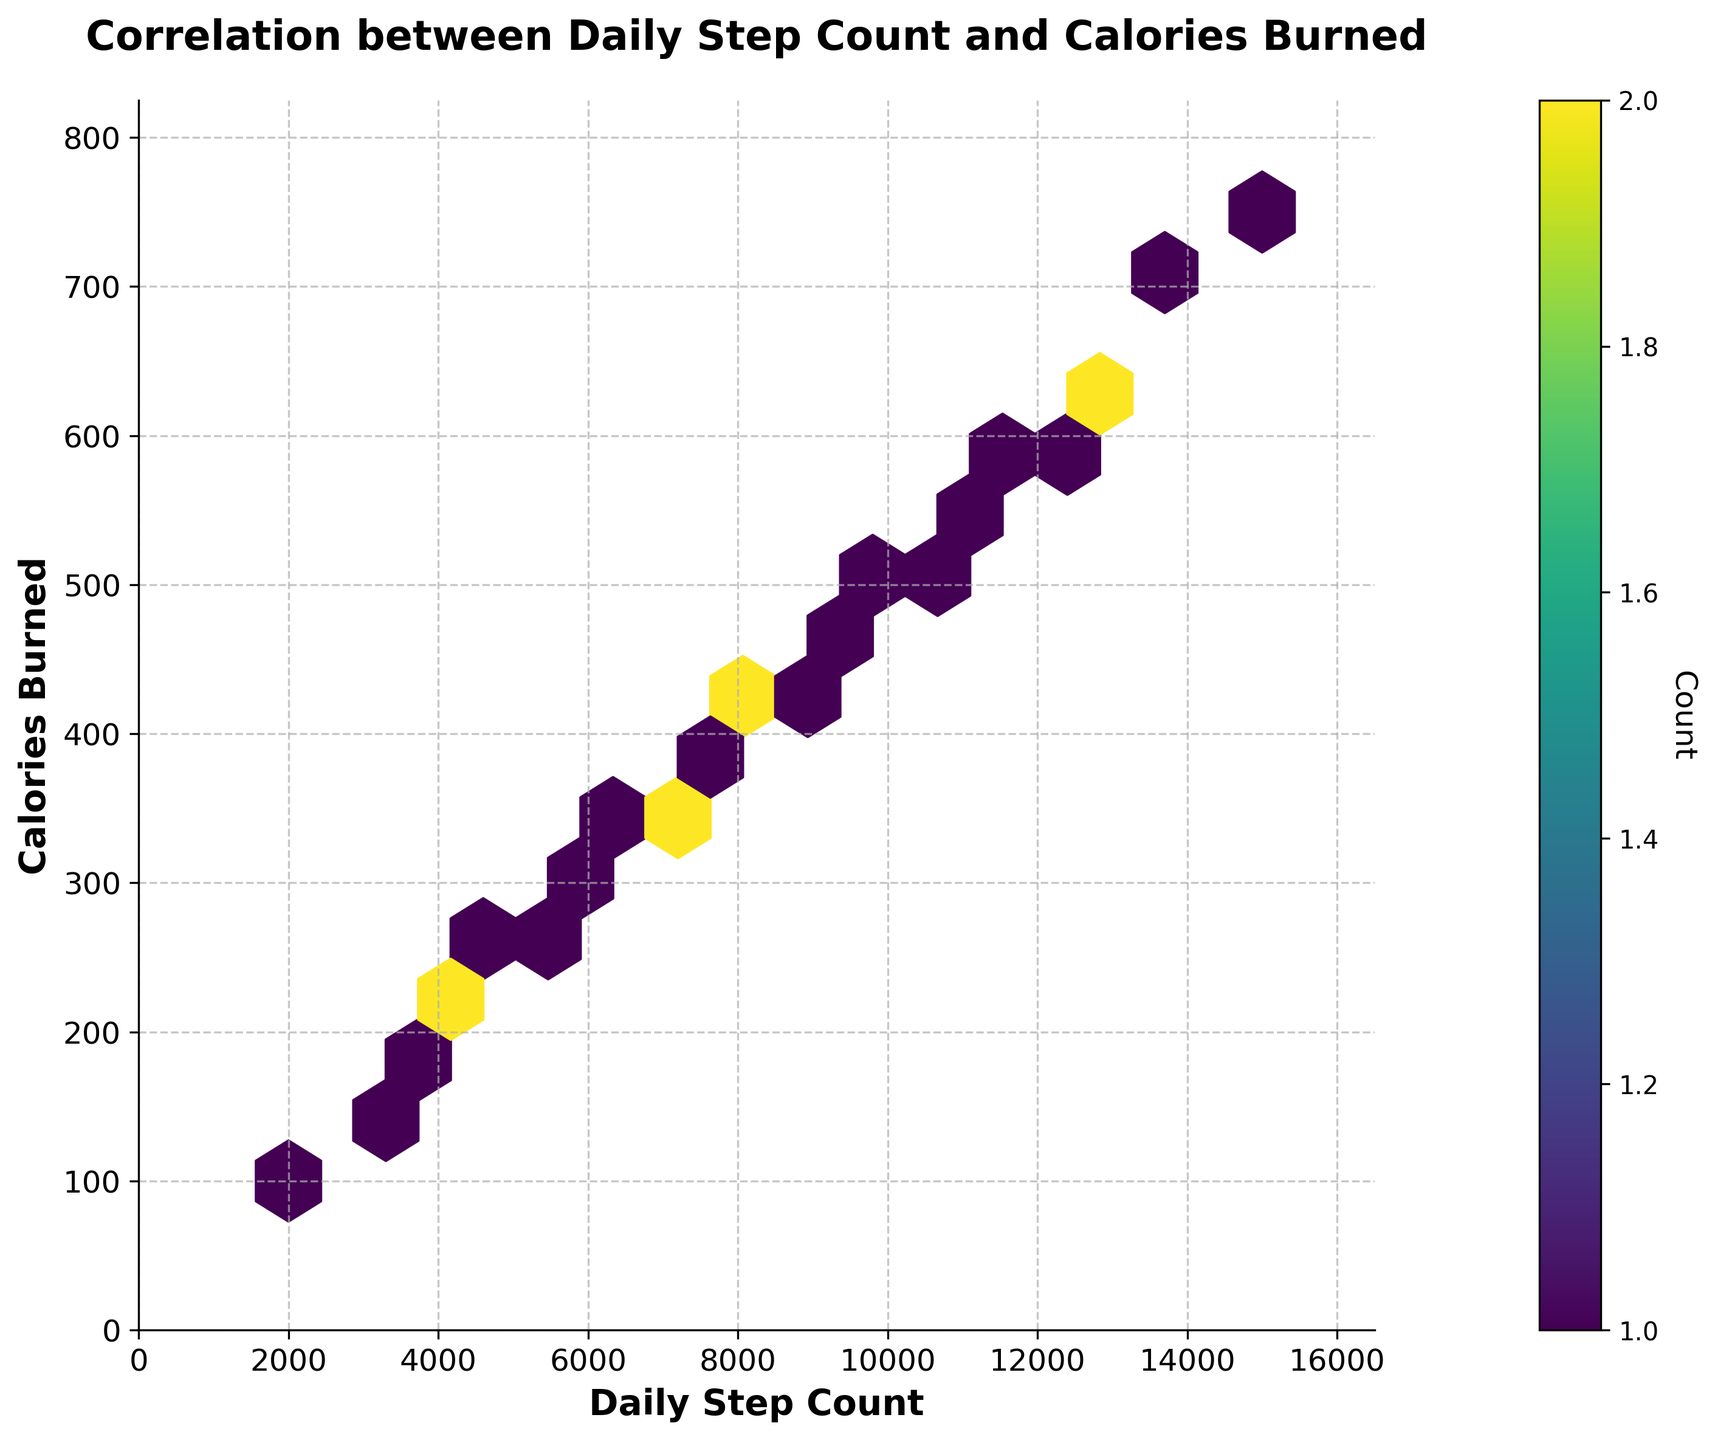What is the title of the figure? The title is clearly displayed at the top center of the figure. It states "Correlation between Daily Step Count and Calories Burned".
Answer: Correlation between Daily Step Count and Calories Burned What are the labels of the x-axis and y-axis? The x-axis is labeled "Daily Step Count" and the y-axis is labeled "Calories Burned".
Answer: Daily Step Count and Calories Burned What does the color intensity in the hexbin plot represent? The color intensity represents the count of fitness app users for a particular combination of daily step count and calories burned. The color bar on the right indicates it.
Answer: Count of users Which hexagons have the highest density of data points? The hexagons with the darkest color (deep purple) indicate the highest density. These appear around the center of the data, roughly at (12500, 625) and (10000, 500).
Answer: Around (12500, 625) and (10000, 500) Is there an overall trend visible between daily step count and calories burned on the plot? The plot shows an upward trend, indicating that as the daily step count increases, the calories burned also increase.
Answer: Yes, upward trend Are there any outliers visible in the plot? Outliers would be points that lie far away from the general trend. There are no significant outliers visible as most hexagons follow the upward trend closely.
Answer: No significant outliers Which daily step count corresponds to burning around 300 calories? By looking at the y-axis at 300 calories and following it to the nearest hexagon, it corresponds to a step count of around 6000-7000 steps.
Answer: Around 6000-7000 steps How does the density of users change as the step count and calories burned increase? The density initially increases, peaking around 12500 steps and 625 calories, and then decreases as both the step count and calories burned increase beyond this point.
Answer: Peaks then decreases What is the maximum value range for daily step count and calories burned on the plot? Based on the x and y axes, the plot extends to around 16000 steps (x-axis) and 825 calories (y-axis).
Answer: Around 16000 steps and 825 calories What is the color of the hexagons with the lowest count of users? The hexagons with the lowest count of users are of a light green color, indicating the minimum density as shown in the color bar.
Answer: Light green 